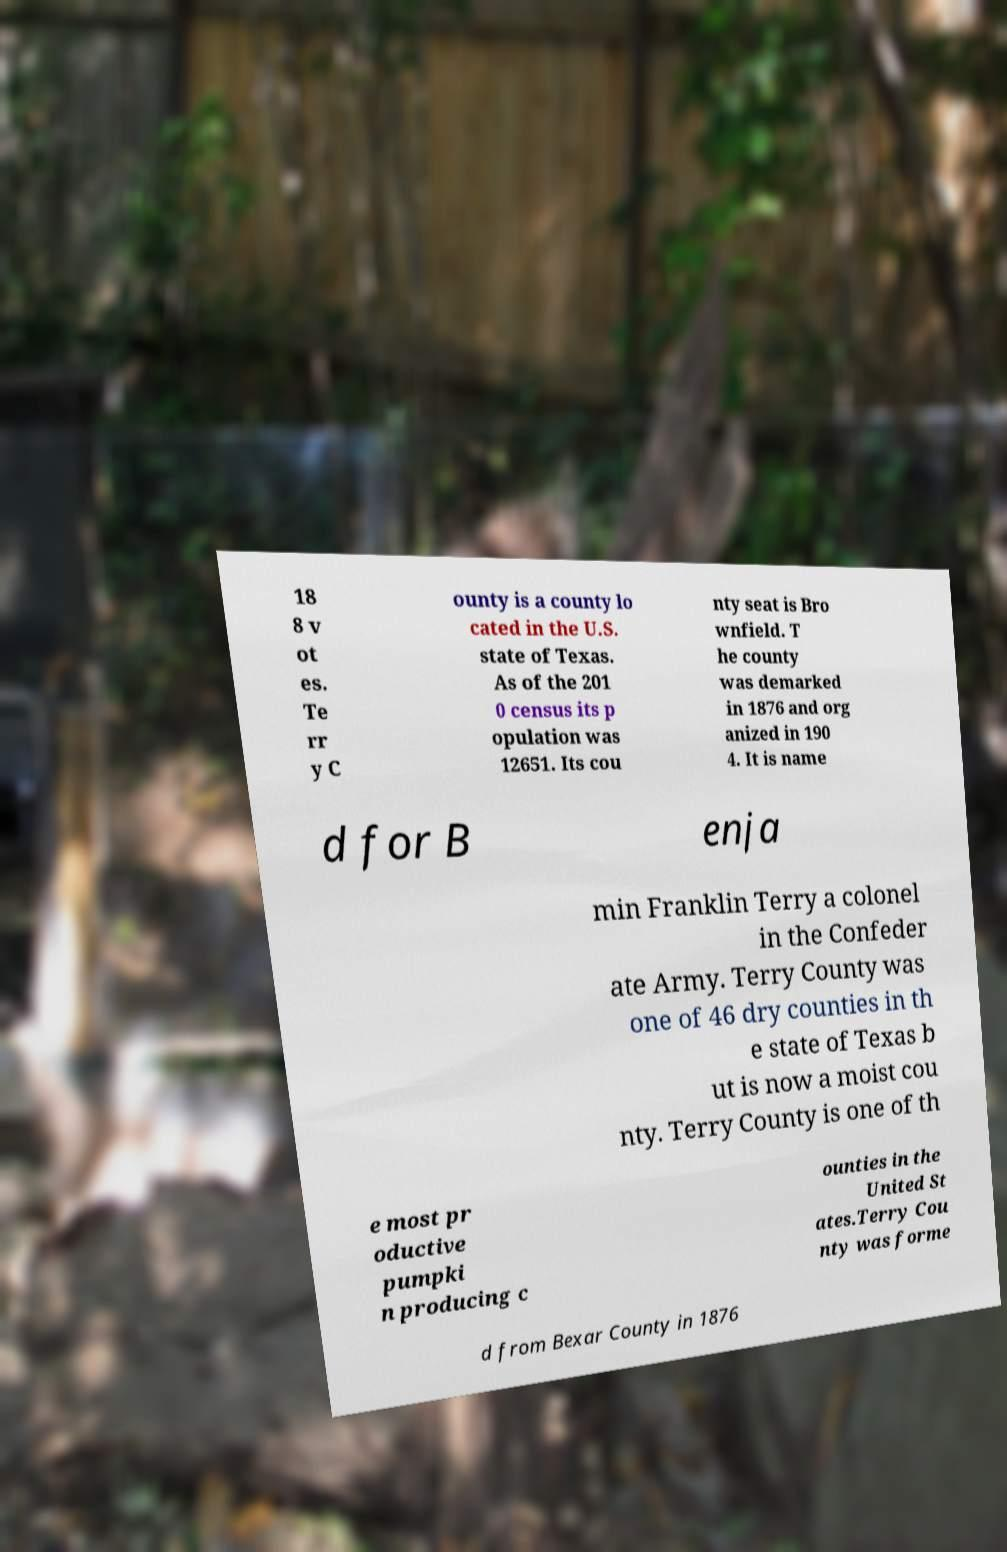There's text embedded in this image that I need extracted. Can you transcribe it verbatim? 18 8 v ot es. Te rr y C ounty is a county lo cated in the U.S. state of Texas. As of the 201 0 census its p opulation was 12651. Its cou nty seat is Bro wnfield. T he county was demarked in 1876 and org anized in 190 4. It is name d for B enja min Franklin Terry a colonel in the Confeder ate Army. Terry County was one of 46 dry counties in th e state of Texas b ut is now a moist cou nty. Terry County is one of th e most pr oductive pumpki n producing c ounties in the United St ates.Terry Cou nty was forme d from Bexar County in 1876 